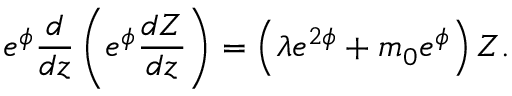Convert formula to latex. <formula><loc_0><loc_0><loc_500><loc_500>e ^ { \phi } \frac { d } { d z } \left ( e ^ { \phi } \frac { d Z } { d z } \right ) = \left ( \lambda e ^ { 2 \phi } + m _ { 0 } e ^ { \phi } \right ) Z .</formula> 